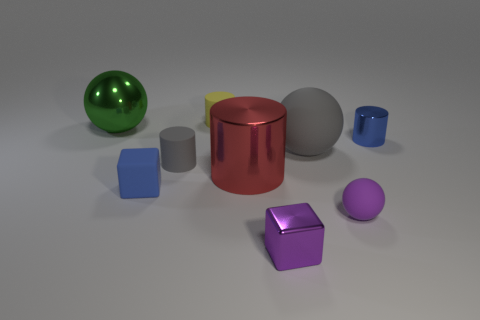What size is the yellow matte object that is the same shape as the tiny gray thing?
Offer a terse response. Small. What is the shape of the big gray thing?
Give a very brief answer. Sphere. Do the big green sphere and the big sphere right of the tiny yellow cylinder have the same material?
Make the answer very short. No. How many metal objects are cylinders or big cylinders?
Keep it short and to the point. 2. What size is the blue object that is behind the large gray thing?
Your response must be concise. Small. There is a gray cylinder that is made of the same material as the small yellow cylinder; what size is it?
Make the answer very short. Small. What number of metal cubes are the same color as the small ball?
Offer a terse response. 1. Is there a big cyan shiny block?
Give a very brief answer. No. Do the red object and the rubber thing behind the blue metallic object have the same shape?
Offer a very short reply. Yes. The cube left of the purple thing that is left of the gray thing that is to the right of the yellow object is what color?
Keep it short and to the point. Blue. 